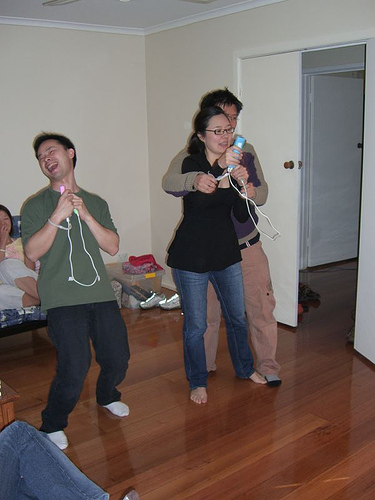<image>What race are the people in the image? I am not sure what race the people in the image are. They could be Asian or Chinese. What race are the people in the image? I am not sure what race the people in the image are. But it can be seen that they are Asian, and some might be Chinese. 